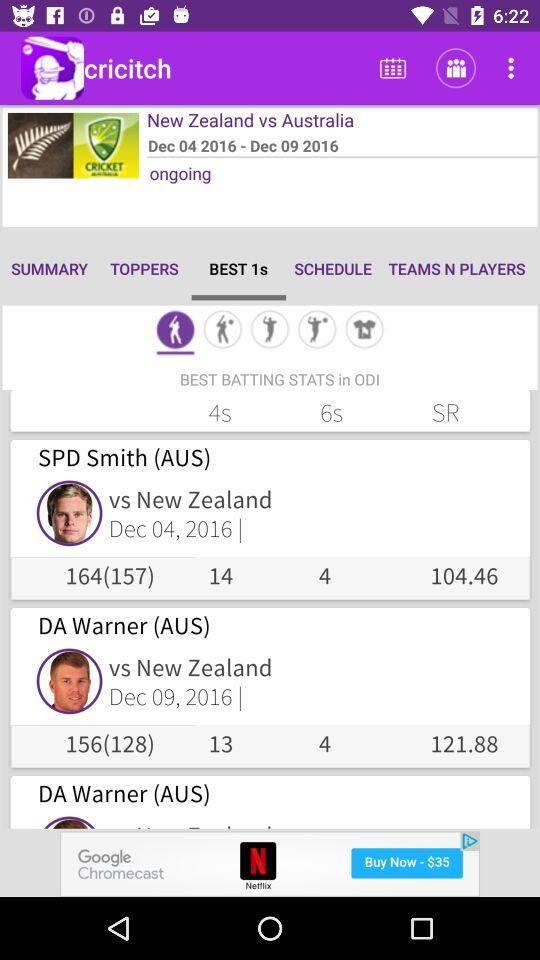Which teams are competing in the ongoing series? The teams are "New Zealand" and "Australia". 